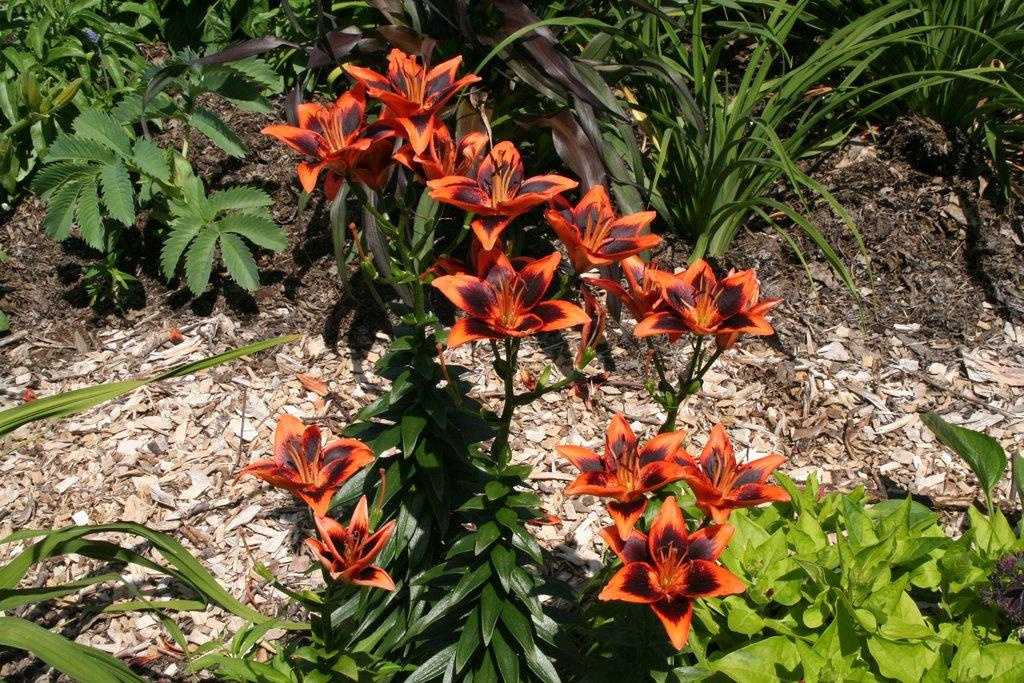What type of living organisms can be seen in the image? There are flowers and plants visible in the image. What other objects can be seen in the image besides living organisms? There are stones in the image. What type of pancake is being used to hold the flowers in the image? There is no pancake present in the image; the flowers are not being held by any pancake. 